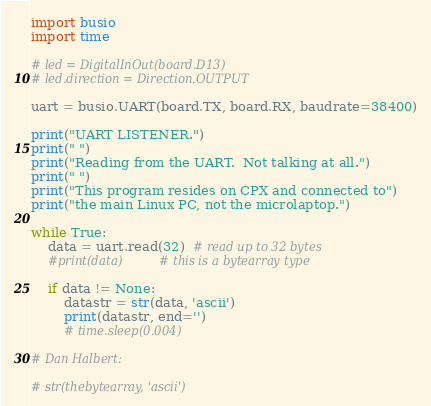<code> <loc_0><loc_0><loc_500><loc_500><_Python_>import busio
import time

# led = DigitalInOut(board.D13)
# led.direction = Direction.OUTPUT

uart = busio.UART(board.TX, board.RX, baudrate=38400)

print("UART LISTENER.")
print(" ")
print("Reading from the UART.  Not talking at all.")
print(" ")
print("This program resides on CPX and connected to")
print("the main Linux PC, not the microlaptop.")

while True:
    data = uart.read(32)  # read up to 32 bytes
    #print(data)          # this is a bytearray type

    if data != None:
        datastr = str(data, 'ascii')
        print(datastr, end='')
        # time.sleep(0.004)

# Dan Halbert:

# str(thebytearray, 'ascii')
</code> 